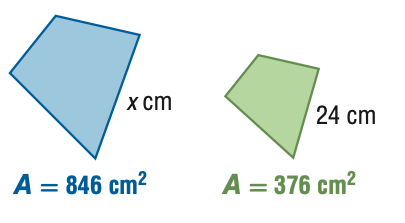Question: For the pair of similar figures, use the given areas to find the scale factor of the blue to the green figure.
Choices:
A. \frac { 4 } { 9 }
B. \frac { 2 } { 3 }
C. \frac { 3 } { 2 }
D. \frac { 9 } { 4 }
Answer with the letter. Answer: C 